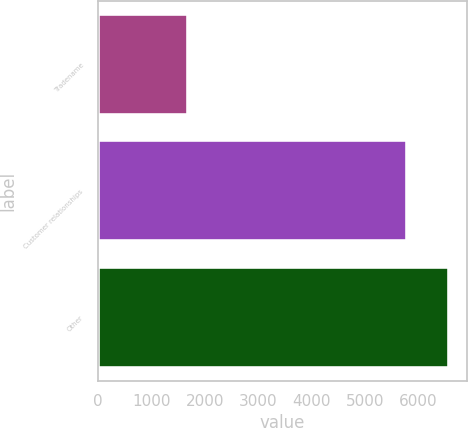Convert chart to OTSL. <chart><loc_0><loc_0><loc_500><loc_500><bar_chart><fcel>Tradename<fcel>Customer relationships<fcel>Other<nl><fcel>1687<fcel>5798<fcel>6582<nl></chart> 